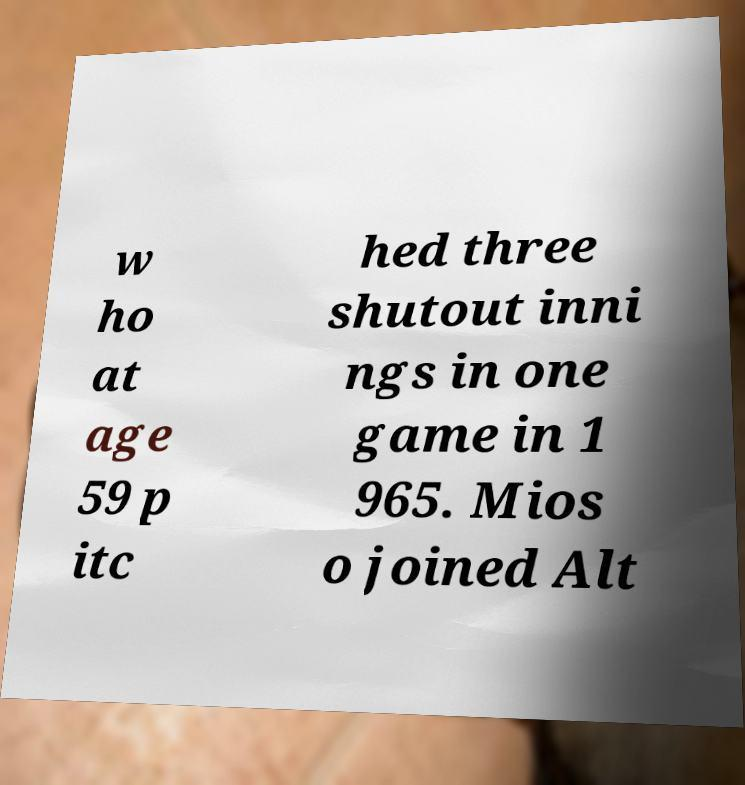There's text embedded in this image that I need extracted. Can you transcribe it verbatim? w ho at age 59 p itc hed three shutout inni ngs in one game in 1 965. Mios o joined Alt 